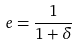<formula> <loc_0><loc_0><loc_500><loc_500>e = \frac { 1 } { 1 + \delta }</formula> 